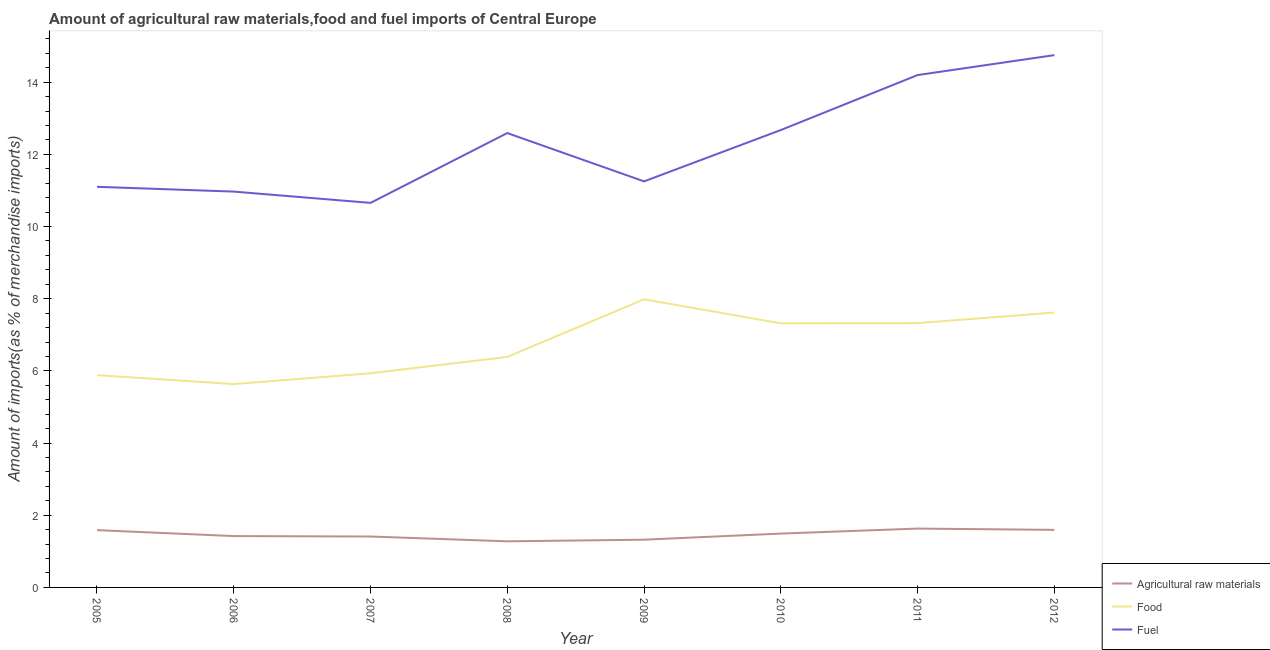How many different coloured lines are there?
Ensure brevity in your answer.  3. What is the percentage of raw materials imports in 2010?
Make the answer very short. 1.49. Across all years, what is the maximum percentage of raw materials imports?
Your response must be concise. 1.63. Across all years, what is the minimum percentage of raw materials imports?
Provide a succinct answer. 1.28. What is the total percentage of fuel imports in the graph?
Keep it short and to the point. 98.19. What is the difference between the percentage of food imports in 2006 and that in 2010?
Your answer should be compact. -1.68. What is the difference between the percentage of raw materials imports in 2007 and the percentage of food imports in 2012?
Keep it short and to the point. -6.21. What is the average percentage of food imports per year?
Offer a terse response. 6.76. In the year 2011, what is the difference between the percentage of fuel imports and percentage of food imports?
Provide a succinct answer. 6.87. What is the ratio of the percentage of fuel imports in 2010 to that in 2011?
Offer a very short reply. 0.89. Is the difference between the percentage of food imports in 2005 and 2011 greater than the difference between the percentage of raw materials imports in 2005 and 2011?
Your response must be concise. No. What is the difference between the highest and the second highest percentage of raw materials imports?
Provide a short and direct response. 0.04. What is the difference between the highest and the lowest percentage of raw materials imports?
Offer a terse response. 0.35. In how many years, is the percentage of food imports greater than the average percentage of food imports taken over all years?
Make the answer very short. 4. Is the sum of the percentage of raw materials imports in 2008 and 2009 greater than the maximum percentage of food imports across all years?
Offer a terse response. No. Is it the case that in every year, the sum of the percentage of raw materials imports and percentage of food imports is greater than the percentage of fuel imports?
Your response must be concise. No. Does the percentage of food imports monotonically increase over the years?
Keep it short and to the point. No. Is the percentage of fuel imports strictly greater than the percentage of raw materials imports over the years?
Keep it short and to the point. Yes. How many years are there in the graph?
Your answer should be very brief. 8. Are the values on the major ticks of Y-axis written in scientific E-notation?
Offer a terse response. No. Does the graph contain any zero values?
Keep it short and to the point. No. Where does the legend appear in the graph?
Provide a short and direct response. Bottom right. How are the legend labels stacked?
Your answer should be compact. Vertical. What is the title of the graph?
Provide a succinct answer. Amount of agricultural raw materials,food and fuel imports of Central Europe. What is the label or title of the X-axis?
Provide a short and direct response. Year. What is the label or title of the Y-axis?
Provide a succinct answer. Amount of imports(as % of merchandise imports). What is the Amount of imports(as % of merchandise imports) in Agricultural raw materials in 2005?
Offer a terse response. 1.59. What is the Amount of imports(as % of merchandise imports) in Food in 2005?
Your answer should be compact. 5.88. What is the Amount of imports(as % of merchandise imports) in Fuel in 2005?
Offer a terse response. 11.1. What is the Amount of imports(as % of merchandise imports) in Agricultural raw materials in 2006?
Your answer should be very brief. 1.42. What is the Amount of imports(as % of merchandise imports) of Food in 2006?
Provide a short and direct response. 5.64. What is the Amount of imports(as % of merchandise imports) of Fuel in 2006?
Provide a short and direct response. 10.97. What is the Amount of imports(as % of merchandise imports) in Agricultural raw materials in 2007?
Offer a very short reply. 1.41. What is the Amount of imports(as % of merchandise imports) in Food in 2007?
Your answer should be very brief. 5.93. What is the Amount of imports(as % of merchandise imports) in Fuel in 2007?
Ensure brevity in your answer.  10.66. What is the Amount of imports(as % of merchandise imports) of Agricultural raw materials in 2008?
Provide a short and direct response. 1.28. What is the Amount of imports(as % of merchandise imports) of Food in 2008?
Provide a short and direct response. 6.39. What is the Amount of imports(as % of merchandise imports) in Fuel in 2008?
Your answer should be compact. 12.59. What is the Amount of imports(as % of merchandise imports) of Agricultural raw materials in 2009?
Your answer should be very brief. 1.32. What is the Amount of imports(as % of merchandise imports) in Food in 2009?
Make the answer very short. 7.98. What is the Amount of imports(as % of merchandise imports) of Fuel in 2009?
Offer a terse response. 11.25. What is the Amount of imports(as % of merchandise imports) of Agricultural raw materials in 2010?
Your answer should be compact. 1.49. What is the Amount of imports(as % of merchandise imports) in Food in 2010?
Make the answer very short. 7.32. What is the Amount of imports(as % of merchandise imports) in Fuel in 2010?
Provide a short and direct response. 12.67. What is the Amount of imports(as % of merchandise imports) of Agricultural raw materials in 2011?
Ensure brevity in your answer.  1.63. What is the Amount of imports(as % of merchandise imports) of Food in 2011?
Provide a short and direct response. 7.32. What is the Amount of imports(as % of merchandise imports) of Fuel in 2011?
Make the answer very short. 14.2. What is the Amount of imports(as % of merchandise imports) in Agricultural raw materials in 2012?
Your answer should be compact. 1.6. What is the Amount of imports(as % of merchandise imports) in Food in 2012?
Offer a terse response. 7.62. What is the Amount of imports(as % of merchandise imports) in Fuel in 2012?
Your answer should be very brief. 14.75. Across all years, what is the maximum Amount of imports(as % of merchandise imports) of Agricultural raw materials?
Ensure brevity in your answer.  1.63. Across all years, what is the maximum Amount of imports(as % of merchandise imports) of Food?
Ensure brevity in your answer.  7.98. Across all years, what is the maximum Amount of imports(as % of merchandise imports) in Fuel?
Provide a short and direct response. 14.75. Across all years, what is the minimum Amount of imports(as % of merchandise imports) of Agricultural raw materials?
Offer a terse response. 1.28. Across all years, what is the minimum Amount of imports(as % of merchandise imports) in Food?
Keep it short and to the point. 5.64. Across all years, what is the minimum Amount of imports(as % of merchandise imports) in Fuel?
Your response must be concise. 10.66. What is the total Amount of imports(as % of merchandise imports) of Agricultural raw materials in the graph?
Provide a succinct answer. 11.74. What is the total Amount of imports(as % of merchandise imports) in Food in the graph?
Ensure brevity in your answer.  54.08. What is the total Amount of imports(as % of merchandise imports) of Fuel in the graph?
Ensure brevity in your answer.  98.19. What is the difference between the Amount of imports(as % of merchandise imports) in Agricultural raw materials in 2005 and that in 2006?
Provide a succinct answer. 0.16. What is the difference between the Amount of imports(as % of merchandise imports) in Food in 2005 and that in 2006?
Your answer should be compact. 0.25. What is the difference between the Amount of imports(as % of merchandise imports) in Fuel in 2005 and that in 2006?
Keep it short and to the point. 0.13. What is the difference between the Amount of imports(as % of merchandise imports) in Agricultural raw materials in 2005 and that in 2007?
Keep it short and to the point. 0.18. What is the difference between the Amount of imports(as % of merchandise imports) in Food in 2005 and that in 2007?
Your answer should be very brief. -0.05. What is the difference between the Amount of imports(as % of merchandise imports) in Fuel in 2005 and that in 2007?
Keep it short and to the point. 0.45. What is the difference between the Amount of imports(as % of merchandise imports) in Agricultural raw materials in 2005 and that in 2008?
Your answer should be very brief. 0.31. What is the difference between the Amount of imports(as % of merchandise imports) in Food in 2005 and that in 2008?
Offer a terse response. -0.5. What is the difference between the Amount of imports(as % of merchandise imports) of Fuel in 2005 and that in 2008?
Provide a short and direct response. -1.49. What is the difference between the Amount of imports(as % of merchandise imports) in Agricultural raw materials in 2005 and that in 2009?
Make the answer very short. 0.26. What is the difference between the Amount of imports(as % of merchandise imports) in Food in 2005 and that in 2009?
Provide a succinct answer. -2.1. What is the difference between the Amount of imports(as % of merchandise imports) of Fuel in 2005 and that in 2009?
Make the answer very short. -0.15. What is the difference between the Amount of imports(as % of merchandise imports) in Agricultural raw materials in 2005 and that in 2010?
Your answer should be very brief. 0.1. What is the difference between the Amount of imports(as % of merchandise imports) in Food in 2005 and that in 2010?
Ensure brevity in your answer.  -1.44. What is the difference between the Amount of imports(as % of merchandise imports) of Fuel in 2005 and that in 2010?
Your response must be concise. -1.57. What is the difference between the Amount of imports(as % of merchandise imports) in Agricultural raw materials in 2005 and that in 2011?
Keep it short and to the point. -0.04. What is the difference between the Amount of imports(as % of merchandise imports) in Food in 2005 and that in 2011?
Give a very brief answer. -1.44. What is the difference between the Amount of imports(as % of merchandise imports) in Fuel in 2005 and that in 2011?
Provide a short and direct response. -3.1. What is the difference between the Amount of imports(as % of merchandise imports) in Agricultural raw materials in 2005 and that in 2012?
Offer a terse response. -0.01. What is the difference between the Amount of imports(as % of merchandise imports) of Food in 2005 and that in 2012?
Your answer should be compact. -1.73. What is the difference between the Amount of imports(as % of merchandise imports) of Fuel in 2005 and that in 2012?
Your response must be concise. -3.65. What is the difference between the Amount of imports(as % of merchandise imports) in Agricultural raw materials in 2006 and that in 2007?
Make the answer very short. 0.01. What is the difference between the Amount of imports(as % of merchandise imports) of Food in 2006 and that in 2007?
Offer a very short reply. -0.3. What is the difference between the Amount of imports(as % of merchandise imports) in Fuel in 2006 and that in 2007?
Provide a succinct answer. 0.31. What is the difference between the Amount of imports(as % of merchandise imports) of Agricultural raw materials in 2006 and that in 2008?
Make the answer very short. 0.15. What is the difference between the Amount of imports(as % of merchandise imports) of Food in 2006 and that in 2008?
Make the answer very short. -0.75. What is the difference between the Amount of imports(as % of merchandise imports) of Fuel in 2006 and that in 2008?
Your answer should be compact. -1.62. What is the difference between the Amount of imports(as % of merchandise imports) of Agricultural raw materials in 2006 and that in 2009?
Provide a short and direct response. 0.1. What is the difference between the Amount of imports(as % of merchandise imports) in Food in 2006 and that in 2009?
Ensure brevity in your answer.  -2.35. What is the difference between the Amount of imports(as % of merchandise imports) of Fuel in 2006 and that in 2009?
Ensure brevity in your answer.  -0.28. What is the difference between the Amount of imports(as % of merchandise imports) of Agricultural raw materials in 2006 and that in 2010?
Provide a succinct answer. -0.07. What is the difference between the Amount of imports(as % of merchandise imports) of Food in 2006 and that in 2010?
Provide a short and direct response. -1.68. What is the difference between the Amount of imports(as % of merchandise imports) in Fuel in 2006 and that in 2010?
Ensure brevity in your answer.  -1.71. What is the difference between the Amount of imports(as % of merchandise imports) in Agricultural raw materials in 2006 and that in 2011?
Provide a succinct answer. -0.21. What is the difference between the Amount of imports(as % of merchandise imports) in Food in 2006 and that in 2011?
Give a very brief answer. -1.69. What is the difference between the Amount of imports(as % of merchandise imports) of Fuel in 2006 and that in 2011?
Make the answer very short. -3.23. What is the difference between the Amount of imports(as % of merchandise imports) of Agricultural raw materials in 2006 and that in 2012?
Your answer should be compact. -0.17. What is the difference between the Amount of imports(as % of merchandise imports) in Food in 2006 and that in 2012?
Your answer should be compact. -1.98. What is the difference between the Amount of imports(as % of merchandise imports) of Fuel in 2006 and that in 2012?
Give a very brief answer. -3.78. What is the difference between the Amount of imports(as % of merchandise imports) of Agricultural raw materials in 2007 and that in 2008?
Provide a short and direct response. 0.13. What is the difference between the Amount of imports(as % of merchandise imports) in Food in 2007 and that in 2008?
Ensure brevity in your answer.  -0.45. What is the difference between the Amount of imports(as % of merchandise imports) of Fuel in 2007 and that in 2008?
Your answer should be very brief. -1.93. What is the difference between the Amount of imports(as % of merchandise imports) in Agricultural raw materials in 2007 and that in 2009?
Ensure brevity in your answer.  0.09. What is the difference between the Amount of imports(as % of merchandise imports) in Food in 2007 and that in 2009?
Your answer should be compact. -2.05. What is the difference between the Amount of imports(as % of merchandise imports) in Fuel in 2007 and that in 2009?
Your answer should be very brief. -0.6. What is the difference between the Amount of imports(as % of merchandise imports) in Agricultural raw materials in 2007 and that in 2010?
Your answer should be very brief. -0.08. What is the difference between the Amount of imports(as % of merchandise imports) of Food in 2007 and that in 2010?
Offer a very short reply. -1.38. What is the difference between the Amount of imports(as % of merchandise imports) in Fuel in 2007 and that in 2010?
Ensure brevity in your answer.  -2.02. What is the difference between the Amount of imports(as % of merchandise imports) of Agricultural raw materials in 2007 and that in 2011?
Offer a terse response. -0.22. What is the difference between the Amount of imports(as % of merchandise imports) in Food in 2007 and that in 2011?
Ensure brevity in your answer.  -1.39. What is the difference between the Amount of imports(as % of merchandise imports) in Fuel in 2007 and that in 2011?
Provide a succinct answer. -3.54. What is the difference between the Amount of imports(as % of merchandise imports) of Agricultural raw materials in 2007 and that in 2012?
Provide a short and direct response. -0.18. What is the difference between the Amount of imports(as % of merchandise imports) in Food in 2007 and that in 2012?
Your answer should be compact. -1.68. What is the difference between the Amount of imports(as % of merchandise imports) in Fuel in 2007 and that in 2012?
Provide a succinct answer. -4.09. What is the difference between the Amount of imports(as % of merchandise imports) of Agricultural raw materials in 2008 and that in 2009?
Your answer should be compact. -0.05. What is the difference between the Amount of imports(as % of merchandise imports) of Food in 2008 and that in 2009?
Your answer should be very brief. -1.6. What is the difference between the Amount of imports(as % of merchandise imports) of Fuel in 2008 and that in 2009?
Your response must be concise. 1.34. What is the difference between the Amount of imports(as % of merchandise imports) in Agricultural raw materials in 2008 and that in 2010?
Give a very brief answer. -0.21. What is the difference between the Amount of imports(as % of merchandise imports) in Food in 2008 and that in 2010?
Ensure brevity in your answer.  -0.93. What is the difference between the Amount of imports(as % of merchandise imports) in Fuel in 2008 and that in 2010?
Offer a very short reply. -0.08. What is the difference between the Amount of imports(as % of merchandise imports) of Agricultural raw materials in 2008 and that in 2011?
Make the answer very short. -0.35. What is the difference between the Amount of imports(as % of merchandise imports) in Food in 2008 and that in 2011?
Offer a terse response. -0.94. What is the difference between the Amount of imports(as % of merchandise imports) of Fuel in 2008 and that in 2011?
Ensure brevity in your answer.  -1.61. What is the difference between the Amount of imports(as % of merchandise imports) of Agricultural raw materials in 2008 and that in 2012?
Offer a terse response. -0.32. What is the difference between the Amount of imports(as % of merchandise imports) in Food in 2008 and that in 2012?
Provide a succinct answer. -1.23. What is the difference between the Amount of imports(as % of merchandise imports) of Fuel in 2008 and that in 2012?
Provide a succinct answer. -2.16. What is the difference between the Amount of imports(as % of merchandise imports) of Agricultural raw materials in 2009 and that in 2010?
Your response must be concise. -0.17. What is the difference between the Amount of imports(as % of merchandise imports) of Food in 2009 and that in 2010?
Your response must be concise. 0.67. What is the difference between the Amount of imports(as % of merchandise imports) in Fuel in 2009 and that in 2010?
Your answer should be very brief. -1.42. What is the difference between the Amount of imports(as % of merchandise imports) of Agricultural raw materials in 2009 and that in 2011?
Your answer should be very brief. -0.31. What is the difference between the Amount of imports(as % of merchandise imports) in Food in 2009 and that in 2011?
Give a very brief answer. 0.66. What is the difference between the Amount of imports(as % of merchandise imports) of Fuel in 2009 and that in 2011?
Offer a very short reply. -2.95. What is the difference between the Amount of imports(as % of merchandise imports) of Agricultural raw materials in 2009 and that in 2012?
Provide a succinct answer. -0.27. What is the difference between the Amount of imports(as % of merchandise imports) in Food in 2009 and that in 2012?
Make the answer very short. 0.37. What is the difference between the Amount of imports(as % of merchandise imports) of Fuel in 2009 and that in 2012?
Offer a terse response. -3.5. What is the difference between the Amount of imports(as % of merchandise imports) of Agricultural raw materials in 2010 and that in 2011?
Provide a short and direct response. -0.14. What is the difference between the Amount of imports(as % of merchandise imports) of Food in 2010 and that in 2011?
Your answer should be compact. -0.01. What is the difference between the Amount of imports(as % of merchandise imports) in Fuel in 2010 and that in 2011?
Your response must be concise. -1.52. What is the difference between the Amount of imports(as % of merchandise imports) of Agricultural raw materials in 2010 and that in 2012?
Make the answer very short. -0.1. What is the difference between the Amount of imports(as % of merchandise imports) of Food in 2010 and that in 2012?
Give a very brief answer. -0.3. What is the difference between the Amount of imports(as % of merchandise imports) of Fuel in 2010 and that in 2012?
Ensure brevity in your answer.  -2.08. What is the difference between the Amount of imports(as % of merchandise imports) in Agricultural raw materials in 2011 and that in 2012?
Provide a succinct answer. 0.04. What is the difference between the Amount of imports(as % of merchandise imports) of Food in 2011 and that in 2012?
Your answer should be very brief. -0.29. What is the difference between the Amount of imports(as % of merchandise imports) of Fuel in 2011 and that in 2012?
Give a very brief answer. -0.55. What is the difference between the Amount of imports(as % of merchandise imports) in Agricultural raw materials in 2005 and the Amount of imports(as % of merchandise imports) in Food in 2006?
Give a very brief answer. -4.05. What is the difference between the Amount of imports(as % of merchandise imports) of Agricultural raw materials in 2005 and the Amount of imports(as % of merchandise imports) of Fuel in 2006?
Offer a terse response. -9.38. What is the difference between the Amount of imports(as % of merchandise imports) in Food in 2005 and the Amount of imports(as % of merchandise imports) in Fuel in 2006?
Your answer should be compact. -5.09. What is the difference between the Amount of imports(as % of merchandise imports) of Agricultural raw materials in 2005 and the Amount of imports(as % of merchandise imports) of Food in 2007?
Offer a terse response. -4.35. What is the difference between the Amount of imports(as % of merchandise imports) in Agricultural raw materials in 2005 and the Amount of imports(as % of merchandise imports) in Fuel in 2007?
Make the answer very short. -9.07. What is the difference between the Amount of imports(as % of merchandise imports) of Food in 2005 and the Amount of imports(as % of merchandise imports) of Fuel in 2007?
Your response must be concise. -4.77. What is the difference between the Amount of imports(as % of merchandise imports) of Agricultural raw materials in 2005 and the Amount of imports(as % of merchandise imports) of Food in 2008?
Give a very brief answer. -4.8. What is the difference between the Amount of imports(as % of merchandise imports) of Agricultural raw materials in 2005 and the Amount of imports(as % of merchandise imports) of Fuel in 2008?
Make the answer very short. -11. What is the difference between the Amount of imports(as % of merchandise imports) of Food in 2005 and the Amount of imports(as % of merchandise imports) of Fuel in 2008?
Offer a very short reply. -6.71. What is the difference between the Amount of imports(as % of merchandise imports) in Agricultural raw materials in 2005 and the Amount of imports(as % of merchandise imports) in Food in 2009?
Your answer should be very brief. -6.4. What is the difference between the Amount of imports(as % of merchandise imports) in Agricultural raw materials in 2005 and the Amount of imports(as % of merchandise imports) in Fuel in 2009?
Ensure brevity in your answer.  -9.66. What is the difference between the Amount of imports(as % of merchandise imports) in Food in 2005 and the Amount of imports(as % of merchandise imports) in Fuel in 2009?
Keep it short and to the point. -5.37. What is the difference between the Amount of imports(as % of merchandise imports) of Agricultural raw materials in 2005 and the Amount of imports(as % of merchandise imports) of Food in 2010?
Your answer should be very brief. -5.73. What is the difference between the Amount of imports(as % of merchandise imports) of Agricultural raw materials in 2005 and the Amount of imports(as % of merchandise imports) of Fuel in 2010?
Offer a very short reply. -11.09. What is the difference between the Amount of imports(as % of merchandise imports) of Food in 2005 and the Amount of imports(as % of merchandise imports) of Fuel in 2010?
Provide a succinct answer. -6.79. What is the difference between the Amount of imports(as % of merchandise imports) of Agricultural raw materials in 2005 and the Amount of imports(as % of merchandise imports) of Food in 2011?
Keep it short and to the point. -5.74. What is the difference between the Amount of imports(as % of merchandise imports) of Agricultural raw materials in 2005 and the Amount of imports(as % of merchandise imports) of Fuel in 2011?
Ensure brevity in your answer.  -12.61. What is the difference between the Amount of imports(as % of merchandise imports) in Food in 2005 and the Amount of imports(as % of merchandise imports) in Fuel in 2011?
Your response must be concise. -8.31. What is the difference between the Amount of imports(as % of merchandise imports) of Agricultural raw materials in 2005 and the Amount of imports(as % of merchandise imports) of Food in 2012?
Offer a very short reply. -6.03. What is the difference between the Amount of imports(as % of merchandise imports) of Agricultural raw materials in 2005 and the Amount of imports(as % of merchandise imports) of Fuel in 2012?
Keep it short and to the point. -13.16. What is the difference between the Amount of imports(as % of merchandise imports) in Food in 2005 and the Amount of imports(as % of merchandise imports) in Fuel in 2012?
Keep it short and to the point. -8.87. What is the difference between the Amount of imports(as % of merchandise imports) in Agricultural raw materials in 2006 and the Amount of imports(as % of merchandise imports) in Food in 2007?
Offer a very short reply. -4.51. What is the difference between the Amount of imports(as % of merchandise imports) of Agricultural raw materials in 2006 and the Amount of imports(as % of merchandise imports) of Fuel in 2007?
Offer a terse response. -9.23. What is the difference between the Amount of imports(as % of merchandise imports) in Food in 2006 and the Amount of imports(as % of merchandise imports) in Fuel in 2007?
Provide a short and direct response. -5.02. What is the difference between the Amount of imports(as % of merchandise imports) in Agricultural raw materials in 2006 and the Amount of imports(as % of merchandise imports) in Food in 2008?
Provide a short and direct response. -4.96. What is the difference between the Amount of imports(as % of merchandise imports) of Agricultural raw materials in 2006 and the Amount of imports(as % of merchandise imports) of Fuel in 2008?
Offer a very short reply. -11.17. What is the difference between the Amount of imports(as % of merchandise imports) of Food in 2006 and the Amount of imports(as % of merchandise imports) of Fuel in 2008?
Your answer should be very brief. -6.96. What is the difference between the Amount of imports(as % of merchandise imports) of Agricultural raw materials in 2006 and the Amount of imports(as % of merchandise imports) of Food in 2009?
Your answer should be compact. -6.56. What is the difference between the Amount of imports(as % of merchandise imports) in Agricultural raw materials in 2006 and the Amount of imports(as % of merchandise imports) in Fuel in 2009?
Offer a very short reply. -9.83. What is the difference between the Amount of imports(as % of merchandise imports) in Food in 2006 and the Amount of imports(as % of merchandise imports) in Fuel in 2009?
Give a very brief answer. -5.62. What is the difference between the Amount of imports(as % of merchandise imports) of Agricultural raw materials in 2006 and the Amount of imports(as % of merchandise imports) of Food in 2010?
Offer a very short reply. -5.9. What is the difference between the Amount of imports(as % of merchandise imports) of Agricultural raw materials in 2006 and the Amount of imports(as % of merchandise imports) of Fuel in 2010?
Provide a succinct answer. -11.25. What is the difference between the Amount of imports(as % of merchandise imports) in Food in 2006 and the Amount of imports(as % of merchandise imports) in Fuel in 2010?
Offer a terse response. -7.04. What is the difference between the Amount of imports(as % of merchandise imports) in Agricultural raw materials in 2006 and the Amount of imports(as % of merchandise imports) in Food in 2011?
Ensure brevity in your answer.  -5.9. What is the difference between the Amount of imports(as % of merchandise imports) in Agricultural raw materials in 2006 and the Amount of imports(as % of merchandise imports) in Fuel in 2011?
Give a very brief answer. -12.77. What is the difference between the Amount of imports(as % of merchandise imports) in Food in 2006 and the Amount of imports(as % of merchandise imports) in Fuel in 2011?
Provide a succinct answer. -8.56. What is the difference between the Amount of imports(as % of merchandise imports) in Agricultural raw materials in 2006 and the Amount of imports(as % of merchandise imports) in Food in 2012?
Your answer should be very brief. -6.19. What is the difference between the Amount of imports(as % of merchandise imports) in Agricultural raw materials in 2006 and the Amount of imports(as % of merchandise imports) in Fuel in 2012?
Your answer should be very brief. -13.33. What is the difference between the Amount of imports(as % of merchandise imports) in Food in 2006 and the Amount of imports(as % of merchandise imports) in Fuel in 2012?
Your answer should be compact. -9.11. What is the difference between the Amount of imports(as % of merchandise imports) of Agricultural raw materials in 2007 and the Amount of imports(as % of merchandise imports) of Food in 2008?
Make the answer very short. -4.98. What is the difference between the Amount of imports(as % of merchandise imports) in Agricultural raw materials in 2007 and the Amount of imports(as % of merchandise imports) in Fuel in 2008?
Give a very brief answer. -11.18. What is the difference between the Amount of imports(as % of merchandise imports) of Food in 2007 and the Amount of imports(as % of merchandise imports) of Fuel in 2008?
Provide a succinct answer. -6.66. What is the difference between the Amount of imports(as % of merchandise imports) in Agricultural raw materials in 2007 and the Amount of imports(as % of merchandise imports) in Food in 2009?
Your answer should be very brief. -6.57. What is the difference between the Amount of imports(as % of merchandise imports) of Agricultural raw materials in 2007 and the Amount of imports(as % of merchandise imports) of Fuel in 2009?
Make the answer very short. -9.84. What is the difference between the Amount of imports(as % of merchandise imports) in Food in 2007 and the Amount of imports(as % of merchandise imports) in Fuel in 2009?
Keep it short and to the point. -5.32. What is the difference between the Amount of imports(as % of merchandise imports) in Agricultural raw materials in 2007 and the Amount of imports(as % of merchandise imports) in Food in 2010?
Provide a succinct answer. -5.91. What is the difference between the Amount of imports(as % of merchandise imports) of Agricultural raw materials in 2007 and the Amount of imports(as % of merchandise imports) of Fuel in 2010?
Offer a terse response. -11.26. What is the difference between the Amount of imports(as % of merchandise imports) of Food in 2007 and the Amount of imports(as % of merchandise imports) of Fuel in 2010?
Your answer should be very brief. -6.74. What is the difference between the Amount of imports(as % of merchandise imports) in Agricultural raw materials in 2007 and the Amount of imports(as % of merchandise imports) in Food in 2011?
Offer a very short reply. -5.91. What is the difference between the Amount of imports(as % of merchandise imports) of Agricultural raw materials in 2007 and the Amount of imports(as % of merchandise imports) of Fuel in 2011?
Give a very brief answer. -12.79. What is the difference between the Amount of imports(as % of merchandise imports) in Food in 2007 and the Amount of imports(as % of merchandise imports) in Fuel in 2011?
Your response must be concise. -8.26. What is the difference between the Amount of imports(as % of merchandise imports) in Agricultural raw materials in 2007 and the Amount of imports(as % of merchandise imports) in Food in 2012?
Offer a very short reply. -6.21. What is the difference between the Amount of imports(as % of merchandise imports) in Agricultural raw materials in 2007 and the Amount of imports(as % of merchandise imports) in Fuel in 2012?
Your answer should be very brief. -13.34. What is the difference between the Amount of imports(as % of merchandise imports) of Food in 2007 and the Amount of imports(as % of merchandise imports) of Fuel in 2012?
Your response must be concise. -8.82. What is the difference between the Amount of imports(as % of merchandise imports) of Agricultural raw materials in 2008 and the Amount of imports(as % of merchandise imports) of Food in 2009?
Keep it short and to the point. -6.71. What is the difference between the Amount of imports(as % of merchandise imports) in Agricultural raw materials in 2008 and the Amount of imports(as % of merchandise imports) in Fuel in 2009?
Ensure brevity in your answer.  -9.97. What is the difference between the Amount of imports(as % of merchandise imports) of Food in 2008 and the Amount of imports(as % of merchandise imports) of Fuel in 2009?
Your answer should be very brief. -4.86. What is the difference between the Amount of imports(as % of merchandise imports) in Agricultural raw materials in 2008 and the Amount of imports(as % of merchandise imports) in Food in 2010?
Provide a short and direct response. -6.04. What is the difference between the Amount of imports(as % of merchandise imports) of Agricultural raw materials in 2008 and the Amount of imports(as % of merchandise imports) of Fuel in 2010?
Ensure brevity in your answer.  -11.4. What is the difference between the Amount of imports(as % of merchandise imports) of Food in 2008 and the Amount of imports(as % of merchandise imports) of Fuel in 2010?
Your answer should be very brief. -6.29. What is the difference between the Amount of imports(as % of merchandise imports) of Agricultural raw materials in 2008 and the Amount of imports(as % of merchandise imports) of Food in 2011?
Your answer should be very brief. -6.05. What is the difference between the Amount of imports(as % of merchandise imports) of Agricultural raw materials in 2008 and the Amount of imports(as % of merchandise imports) of Fuel in 2011?
Keep it short and to the point. -12.92. What is the difference between the Amount of imports(as % of merchandise imports) in Food in 2008 and the Amount of imports(as % of merchandise imports) in Fuel in 2011?
Make the answer very short. -7.81. What is the difference between the Amount of imports(as % of merchandise imports) of Agricultural raw materials in 2008 and the Amount of imports(as % of merchandise imports) of Food in 2012?
Provide a short and direct response. -6.34. What is the difference between the Amount of imports(as % of merchandise imports) in Agricultural raw materials in 2008 and the Amount of imports(as % of merchandise imports) in Fuel in 2012?
Ensure brevity in your answer.  -13.47. What is the difference between the Amount of imports(as % of merchandise imports) in Food in 2008 and the Amount of imports(as % of merchandise imports) in Fuel in 2012?
Offer a terse response. -8.36. What is the difference between the Amount of imports(as % of merchandise imports) of Agricultural raw materials in 2009 and the Amount of imports(as % of merchandise imports) of Food in 2010?
Offer a terse response. -6. What is the difference between the Amount of imports(as % of merchandise imports) in Agricultural raw materials in 2009 and the Amount of imports(as % of merchandise imports) in Fuel in 2010?
Provide a short and direct response. -11.35. What is the difference between the Amount of imports(as % of merchandise imports) in Food in 2009 and the Amount of imports(as % of merchandise imports) in Fuel in 2010?
Your answer should be very brief. -4.69. What is the difference between the Amount of imports(as % of merchandise imports) in Agricultural raw materials in 2009 and the Amount of imports(as % of merchandise imports) in Food in 2011?
Give a very brief answer. -6. What is the difference between the Amount of imports(as % of merchandise imports) in Agricultural raw materials in 2009 and the Amount of imports(as % of merchandise imports) in Fuel in 2011?
Your answer should be very brief. -12.87. What is the difference between the Amount of imports(as % of merchandise imports) of Food in 2009 and the Amount of imports(as % of merchandise imports) of Fuel in 2011?
Your answer should be very brief. -6.21. What is the difference between the Amount of imports(as % of merchandise imports) of Agricultural raw materials in 2009 and the Amount of imports(as % of merchandise imports) of Food in 2012?
Your response must be concise. -6.29. What is the difference between the Amount of imports(as % of merchandise imports) in Agricultural raw materials in 2009 and the Amount of imports(as % of merchandise imports) in Fuel in 2012?
Make the answer very short. -13.43. What is the difference between the Amount of imports(as % of merchandise imports) of Food in 2009 and the Amount of imports(as % of merchandise imports) of Fuel in 2012?
Ensure brevity in your answer.  -6.77. What is the difference between the Amount of imports(as % of merchandise imports) of Agricultural raw materials in 2010 and the Amount of imports(as % of merchandise imports) of Food in 2011?
Your response must be concise. -5.83. What is the difference between the Amount of imports(as % of merchandise imports) of Agricultural raw materials in 2010 and the Amount of imports(as % of merchandise imports) of Fuel in 2011?
Provide a short and direct response. -12.71. What is the difference between the Amount of imports(as % of merchandise imports) of Food in 2010 and the Amount of imports(as % of merchandise imports) of Fuel in 2011?
Your answer should be very brief. -6.88. What is the difference between the Amount of imports(as % of merchandise imports) in Agricultural raw materials in 2010 and the Amount of imports(as % of merchandise imports) in Food in 2012?
Make the answer very short. -6.12. What is the difference between the Amount of imports(as % of merchandise imports) of Agricultural raw materials in 2010 and the Amount of imports(as % of merchandise imports) of Fuel in 2012?
Make the answer very short. -13.26. What is the difference between the Amount of imports(as % of merchandise imports) of Food in 2010 and the Amount of imports(as % of merchandise imports) of Fuel in 2012?
Provide a short and direct response. -7.43. What is the difference between the Amount of imports(as % of merchandise imports) in Agricultural raw materials in 2011 and the Amount of imports(as % of merchandise imports) in Food in 2012?
Ensure brevity in your answer.  -5.99. What is the difference between the Amount of imports(as % of merchandise imports) of Agricultural raw materials in 2011 and the Amount of imports(as % of merchandise imports) of Fuel in 2012?
Your answer should be very brief. -13.12. What is the difference between the Amount of imports(as % of merchandise imports) of Food in 2011 and the Amount of imports(as % of merchandise imports) of Fuel in 2012?
Keep it short and to the point. -7.43. What is the average Amount of imports(as % of merchandise imports) in Agricultural raw materials per year?
Offer a terse response. 1.47. What is the average Amount of imports(as % of merchandise imports) in Food per year?
Give a very brief answer. 6.76. What is the average Amount of imports(as % of merchandise imports) in Fuel per year?
Your response must be concise. 12.27. In the year 2005, what is the difference between the Amount of imports(as % of merchandise imports) in Agricultural raw materials and Amount of imports(as % of merchandise imports) in Food?
Your response must be concise. -4.3. In the year 2005, what is the difference between the Amount of imports(as % of merchandise imports) in Agricultural raw materials and Amount of imports(as % of merchandise imports) in Fuel?
Make the answer very short. -9.51. In the year 2005, what is the difference between the Amount of imports(as % of merchandise imports) in Food and Amount of imports(as % of merchandise imports) in Fuel?
Keep it short and to the point. -5.22. In the year 2006, what is the difference between the Amount of imports(as % of merchandise imports) of Agricultural raw materials and Amount of imports(as % of merchandise imports) of Food?
Ensure brevity in your answer.  -4.21. In the year 2006, what is the difference between the Amount of imports(as % of merchandise imports) of Agricultural raw materials and Amount of imports(as % of merchandise imports) of Fuel?
Make the answer very short. -9.55. In the year 2006, what is the difference between the Amount of imports(as % of merchandise imports) of Food and Amount of imports(as % of merchandise imports) of Fuel?
Give a very brief answer. -5.33. In the year 2007, what is the difference between the Amount of imports(as % of merchandise imports) of Agricultural raw materials and Amount of imports(as % of merchandise imports) of Food?
Keep it short and to the point. -4.52. In the year 2007, what is the difference between the Amount of imports(as % of merchandise imports) in Agricultural raw materials and Amount of imports(as % of merchandise imports) in Fuel?
Make the answer very short. -9.25. In the year 2007, what is the difference between the Amount of imports(as % of merchandise imports) of Food and Amount of imports(as % of merchandise imports) of Fuel?
Offer a very short reply. -4.72. In the year 2008, what is the difference between the Amount of imports(as % of merchandise imports) of Agricultural raw materials and Amount of imports(as % of merchandise imports) of Food?
Make the answer very short. -5.11. In the year 2008, what is the difference between the Amount of imports(as % of merchandise imports) in Agricultural raw materials and Amount of imports(as % of merchandise imports) in Fuel?
Your answer should be very brief. -11.31. In the year 2008, what is the difference between the Amount of imports(as % of merchandise imports) in Food and Amount of imports(as % of merchandise imports) in Fuel?
Your answer should be compact. -6.2. In the year 2009, what is the difference between the Amount of imports(as % of merchandise imports) of Agricultural raw materials and Amount of imports(as % of merchandise imports) of Food?
Your answer should be compact. -6.66. In the year 2009, what is the difference between the Amount of imports(as % of merchandise imports) of Agricultural raw materials and Amount of imports(as % of merchandise imports) of Fuel?
Your response must be concise. -9.93. In the year 2009, what is the difference between the Amount of imports(as % of merchandise imports) of Food and Amount of imports(as % of merchandise imports) of Fuel?
Your answer should be very brief. -3.27. In the year 2010, what is the difference between the Amount of imports(as % of merchandise imports) in Agricultural raw materials and Amount of imports(as % of merchandise imports) in Food?
Give a very brief answer. -5.83. In the year 2010, what is the difference between the Amount of imports(as % of merchandise imports) of Agricultural raw materials and Amount of imports(as % of merchandise imports) of Fuel?
Make the answer very short. -11.18. In the year 2010, what is the difference between the Amount of imports(as % of merchandise imports) of Food and Amount of imports(as % of merchandise imports) of Fuel?
Ensure brevity in your answer.  -5.36. In the year 2011, what is the difference between the Amount of imports(as % of merchandise imports) of Agricultural raw materials and Amount of imports(as % of merchandise imports) of Food?
Offer a very short reply. -5.69. In the year 2011, what is the difference between the Amount of imports(as % of merchandise imports) in Agricultural raw materials and Amount of imports(as % of merchandise imports) in Fuel?
Your answer should be very brief. -12.57. In the year 2011, what is the difference between the Amount of imports(as % of merchandise imports) of Food and Amount of imports(as % of merchandise imports) of Fuel?
Your answer should be compact. -6.87. In the year 2012, what is the difference between the Amount of imports(as % of merchandise imports) in Agricultural raw materials and Amount of imports(as % of merchandise imports) in Food?
Ensure brevity in your answer.  -6.02. In the year 2012, what is the difference between the Amount of imports(as % of merchandise imports) of Agricultural raw materials and Amount of imports(as % of merchandise imports) of Fuel?
Your answer should be compact. -13.15. In the year 2012, what is the difference between the Amount of imports(as % of merchandise imports) of Food and Amount of imports(as % of merchandise imports) of Fuel?
Provide a short and direct response. -7.13. What is the ratio of the Amount of imports(as % of merchandise imports) in Agricultural raw materials in 2005 to that in 2006?
Give a very brief answer. 1.12. What is the ratio of the Amount of imports(as % of merchandise imports) in Food in 2005 to that in 2006?
Offer a very short reply. 1.04. What is the ratio of the Amount of imports(as % of merchandise imports) in Fuel in 2005 to that in 2006?
Provide a succinct answer. 1.01. What is the ratio of the Amount of imports(as % of merchandise imports) of Agricultural raw materials in 2005 to that in 2007?
Provide a short and direct response. 1.13. What is the ratio of the Amount of imports(as % of merchandise imports) in Food in 2005 to that in 2007?
Your answer should be very brief. 0.99. What is the ratio of the Amount of imports(as % of merchandise imports) in Fuel in 2005 to that in 2007?
Provide a succinct answer. 1.04. What is the ratio of the Amount of imports(as % of merchandise imports) in Agricultural raw materials in 2005 to that in 2008?
Keep it short and to the point. 1.24. What is the ratio of the Amount of imports(as % of merchandise imports) in Food in 2005 to that in 2008?
Provide a succinct answer. 0.92. What is the ratio of the Amount of imports(as % of merchandise imports) of Fuel in 2005 to that in 2008?
Your response must be concise. 0.88. What is the ratio of the Amount of imports(as % of merchandise imports) of Agricultural raw materials in 2005 to that in 2009?
Your answer should be very brief. 1.2. What is the ratio of the Amount of imports(as % of merchandise imports) in Food in 2005 to that in 2009?
Give a very brief answer. 0.74. What is the ratio of the Amount of imports(as % of merchandise imports) in Fuel in 2005 to that in 2009?
Your answer should be compact. 0.99. What is the ratio of the Amount of imports(as % of merchandise imports) of Agricultural raw materials in 2005 to that in 2010?
Your response must be concise. 1.06. What is the ratio of the Amount of imports(as % of merchandise imports) in Food in 2005 to that in 2010?
Make the answer very short. 0.8. What is the ratio of the Amount of imports(as % of merchandise imports) of Fuel in 2005 to that in 2010?
Offer a very short reply. 0.88. What is the ratio of the Amount of imports(as % of merchandise imports) of Agricultural raw materials in 2005 to that in 2011?
Ensure brevity in your answer.  0.97. What is the ratio of the Amount of imports(as % of merchandise imports) in Food in 2005 to that in 2011?
Your response must be concise. 0.8. What is the ratio of the Amount of imports(as % of merchandise imports) in Fuel in 2005 to that in 2011?
Your response must be concise. 0.78. What is the ratio of the Amount of imports(as % of merchandise imports) in Food in 2005 to that in 2012?
Offer a terse response. 0.77. What is the ratio of the Amount of imports(as % of merchandise imports) of Fuel in 2005 to that in 2012?
Provide a succinct answer. 0.75. What is the ratio of the Amount of imports(as % of merchandise imports) in Agricultural raw materials in 2006 to that in 2007?
Offer a very short reply. 1.01. What is the ratio of the Amount of imports(as % of merchandise imports) in Food in 2006 to that in 2007?
Provide a short and direct response. 0.95. What is the ratio of the Amount of imports(as % of merchandise imports) in Fuel in 2006 to that in 2007?
Your answer should be very brief. 1.03. What is the ratio of the Amount of imports(as % of merchandise imports) of Agricultural raw materials in 2006 to that in 2008?
Give a very brief answer. 1.11. What is the ratio of the Amount of imports(as % of merchandise imports) in Food in 2006 to that in 2008?
Make the answer very short. 0.88. What is the ratio of the Amount of imports(as % of merchandise imports) of Fuel in 2006 to that in 2008?
Keep it short and to the point. 0.87. What is the ratio of the Amount of imports(as % of merchandise imports) of Agricultural raw materials in 2006 to that in 2009?
Ensure brevity in your answer.  1.08. What is the ratio of the Amount of imports(as % of merchandise imports) of Food in 2006 to that in 2009?
Keep it short and to the point. 0.71. What is the ratio of the Amount of imports(as % of merchandise imports) in Fuel in 2006 to that in 2009?
Your response must be concise. 0.97. What is the ratio of the Amount of imports(as % of merchandise imports) of Agricultural raw materials in 2006 to that in 2010?
Your answer should be very brief. 0.95. What is the ratio of the Amount of imports(as % of merchandise imports) of Food in 2006 to that in 2010?
Ensure brevity in your answer.  0.77. What is the ratio of the Amount of imports(as % of merchandise imports) of Fuel in 2006 to that in 2010?
Your answer should be very brief. 0.87. What is the ratio of the Amount of imports(as % of merchandise imports) of Agricultural raw materials in 2006 to that in 2011?
Your answer should be very brief. 0.87. What is the ratio of the Amount of imports(as % of merchandise imports) of Food in 2006 to that in 2011?
Your answer should be compact. 0.77. What is the ratio of the Amount of imports(as % of merchandise imports) in Fuel in 2006 to that in 2011?
Keep it short and to the point. 0.77. What is the ratio of the Amount of imports(as % of merchandise imports) of Agricultural raw materials in 2006 to that in 2012?
Your response must be concise. 0.89. What is the ratio of the Amount of imports(as % of merchandise imports) of Food in 2006 to that in 2012?
Keep it short and to the point. 0.74. What is the ratio of the Amount of imports(as % of merchandise imports) of Fuel in 2006 to that in 2012?
Your response must be concise. 0.74. What is the ratio of the Amount of imports(as % of merchandise imports) in Agricultural raw materials in 2007 to that in 2008?
Make the answer very short. 1.1. What is the ratio of the Amount of imports(as % of merchandise imports) of Food in 2007 to that in 2008?
Offer a terse response. 0.93. What is the ratio of the Amount of imports(as % of merchandise imports) of Fuel in 2007 to that in 2008?
Your response must be concise. 0.85. What is the ratio of the Amount of imports(as % of merchandise imports) in Agricultural raw materials in 2007 to that in 2009?
Provide a short and direct response. 1.07. What is the ratio of the Amount of imports(as % of merchandise imports) of Food in 2007 to that in 2009?
Your answer should be very brief. 0.74. What is the ratio of the Amount of imports(as % of merchandise imports) of Fuel in 2007 to that in 2009?
Your response must be concise. 0.95. What is the ratio of the Amount of imports(as % of merchandise imports) of Agricultural raw materials in 2007 to that in 2010?
Ensure brevity in your answer.  0.95. What is the ratio of the Amount of imports(as % of merchandise imports) in Food in 2007 to that in 2010?
Make the answer very short. 0.81. What is the ratio of the Amount of imports(as % of merchandise imports) in Fuel in 2007 to that in 2010?
Keep it short and to the point. 0.84. What is the ratio of the Amount of imports(as % of merchandise imports) in Agricultural raw materials in 2007 to that in 2011?
Provide a short and direct response. 0.87. What is the ratio of the Amount of imports(as % of merchandise imports) of Food in 2007 to that in 2011?
Offer a very short reply. 0.81. What is the ratio of the Amount of imports(as % of merchandise imports) of Fuel in 2007 to that in 2011?
Give a very brief answer. 0.75. What is the ratio of the Amount of imports(as % of merchandise imports) in Agricultural raw materials in 2007 to that in 2012?
Offer a very short reply. 0.88. What is the ratio of the Amount of imports(as % of merchandise imports) in Food in 2007 to that in 2012?
Give a very brief answer. 0.78. What is the ratio of the Amount of imports(as % of merchandise imports) of Fuel in 2007 to that in 2012?
Offer a very short reply. 0.72. What is the ratio of the Amount of imports(as % of merchandise imports) of Agricultural raw materials in 2008 to that in 2009?
Ensure brevity in your answer.  0.97. What is the ratio of the Amount of imports(as % of merchandise imports) in Food in 2008 to that in 2009?
Give a very brief answer. 0.8. What is the ratio of the Amount of imports(as % of merchandise imports) in Fuel in 2008 to that in 2009?
Offer a terse response. 1.12. What is the ratio of the Amount of imports(as % of merchandise imports) in Agricultural raw materials in 2008 to that in 2010?
Provide a succinct answer. 0.86. What is the ratio of the Amount of imports(as % of merchandise imports) of Food in 2008 to that in 2010?
Your response must be concise. 0.87. What is the ratio of the Amount of imports(as % of merchandise imports) in Fuel in 2008 to that in 2010?
Keep it short and to the point. 0.99. What is the ratio of the Amount of imports(as % of merchandise imports) in Agricultural raw materials in 2008 to that in 2011?
Your answer should be compact. 0.78. What is the ratio of the Amount of imports(as % of merchandise imports) of Food in 2008 to that in 2011?
Ensure brevity in your answer.  0.87. What is the ratio of the Amount of imports(as % of merchandise imports) in Fuel in 2008 to that in 2011?
Make the answer very short. 0.89. What is the ratio of the Amount of imports(as % of merchandise imports) of Agricultural raw materials in 2008 to that in 2012?
Your response must be concise. 0.8. What is the ratio of the Amount of imports(as % of merchandise imports) of Food in 2008 to that in 2012?
Offer a very short reply. 0.84. What is the ratio of the Amount of imports(as % of merchandise imports) in Fuel in 2008 to that in 2012?
Ensure brevity in your answer.  0.85. What is the ratio of the Amount of imports(as % of merchandise imports) in Agricultural raw materials in 2009 to that in 2010?
Ensure brevity in your answer.  0.89. What is the ratio of the Amount of imports(as % of merchandise imports) in Food in 2009 to that in 2010?
Ensure brevity in your answer.  1.09. What is the ratio of the Amount of imports(as % of merchandise imports) in Fuel in 2009 to that in 2010?
Provide a short and direct response. 0.89. What is the ratio of the Amount of imports(as % of merchandise imports) of Agricultural raw materials in 2009 to that in 2011?
Keep it short and to the point. 0.81. What is the ratio of the Amount of imports(as % of merchandise imports) in Food in 2009 to that in 2011?
Give a very brief answer. 1.09. What is the ratio of the Amount of imports(as % of merchandise imports) in Fuel in 2009 to that in 2011?
Your answer should be compact. 0.79. What is the ratio of the Amount of imports(as % of merchandise imports) of Agricultural raw materials in 2009 to that in 2012?
Ensure brevity in your answer.  0.83. What is the ratio of the Amount of imports(as % of merchandise imports) in Food in 2009 to that in 2012?
Your answer should be very brief. 1.05. What is the ratio of the Amount of imports(as % of merchandise imports) of Fuel in 2009 to that in 2012?
Provide a succinct answer. 0.76. What is the ratio of the Amount of imports(as % of merchandise imports) in Agricultural raw materials in 2010 to that in 2011?
Make the answer very short. 0.92. What is the ratio of the Amount of imports(as % of merchandise imports) of Fuel in 2010 to that in 2011?
Your response must be concise. 0.89. What is the ratio of the Amount of imports(as % of merchandise imports) in Agricultural raw materials in 2010 to that in 2012?
Keep it short and to the point. 0.94. What is the ratio of the Amount of imports(as % of merchandise imports) in Food in 2010 to that in 2012?
Your answer should be very brief. 0.96. What is the ratio of the Amount of imports(as % of merchandise imports) in Fuel in 2010 to that in 2012?
Make the answer very short. 0.86. What is the ratio of the Amount of imports(as % of merchandise imports) in Agricultural raw materials in 2011 to that in 2012?
Keep it short and to the point. 1.02. What is the ratio of the Amount of imports(as % of merchandise imports) of Food in 2011 to that in 2012?
Keep it short and to the point. 0.96. What is the ratio of the Amount of imports(as % of merchandise imports) in Fuel in 2011 to that in 2012?
Ensure brevity in your answer.  0.96. What is the difference between the highest and the second highest Amount of imports(as % of merchandise imports) of Agricultural raw materials?
Your response must be concise. 0.04. What is the difference between the highest and the second highest Amount of imports(as % of merchandise imports) of Food?
Provide a short and direct response. 0.37. What is the difference between the highest and the second highest Amount of imports(as % of merchandise imports) in Fuel?
Provide a short and direct response. 0.55. What is the difference between the highest and the lowest Amount of imports(as % of merchandise imports) in Agricultural raw materials?
Your response must be concise. 0.35. What is the difference between the highest and the lowest Amount of imports(as % of merchandise imports) of Food?
Make the answer very short. 2.35. What is the difference between the highest and the lowest Amount of imports(as % of merchandise imports) of Fuel?
Make the answer very short. 4.09. 